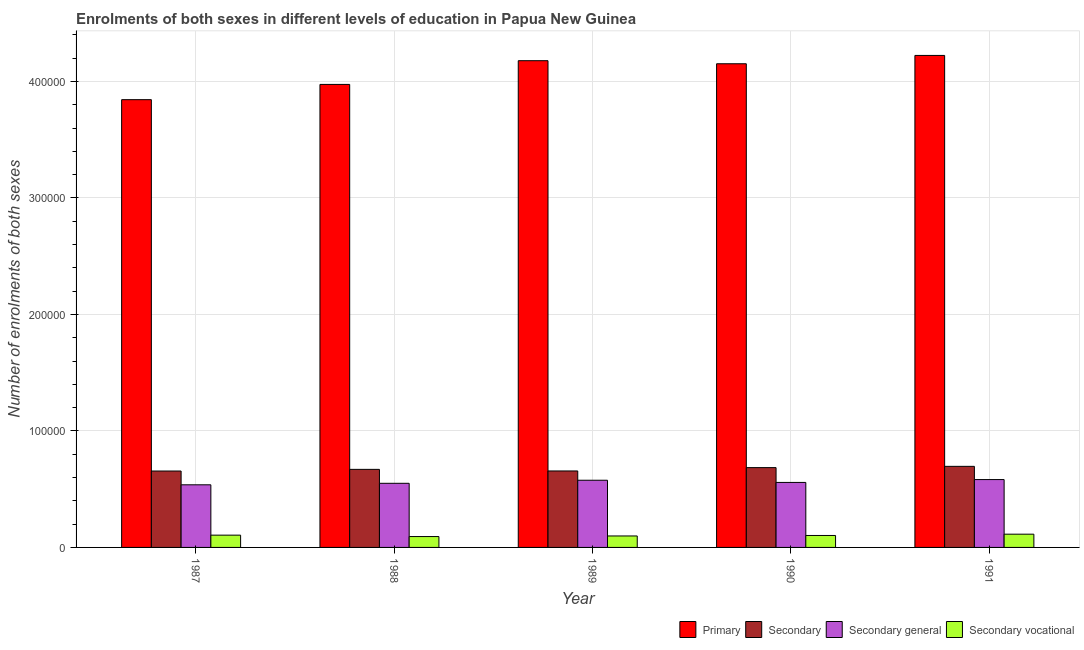Are the number of bars per tick equal to the number of legend labels?
Ensure brevity in your answer.  Yes. Are the number of bars on each tick of the X-axis equal?
Provide a succinct answer. Yes. How many bars are there on the 3rd tick from the left?
Provide a succinct answer. 4. What is the number of enrolments in secondary vocational education in 1990?
Your answer should be very brief. 1.03e+04. Across all years, what is the maximum number of enrolments in secondary vocational education?
Keep it short and to the point. 1.14e+04. Across all years, what is the minimum number of enrolments in secondary vocational education?
Your response must be concise. 9331. In which year was the number of enrolments in primary education maximum?
Your answer should be very brief. 1991. In which year was the number of enrolments in primary education minimum?
Your answer should be compact. 1987. What is the total number of enrolments in primary education in the graph?
Your response must be concise. 2.04e+06. What is the difference between the number of enrolments in primary education in 1987 and that in 1991?
Provide a succinct answer. -3.80e+04. What is the difference between the number of enrolments in secondary general education in 1988 and the number of enrolments in primary education in 1990?
Keep it short and to the point. -751. What is the average number of enrolments in secondary education per year?
Offer a terse response. 6.73e+04. In how many years, is the number of enrolments in primary education greater than 420000?
Make the answer very short. 1. What is the ratio of the number of enrolments in secondary education in 1988 to that in 1989?
Your answer should be very brief. 1.02. What is the difference between the highest and the second highest number of enrolments in secondary general education?
Give a very brief answer. 573. What is the difference between the highest and the lowest number of enrolments in secondary education?
Give a very brief answer. 4014. In how many years, is the number of enrolments in secondary vocational education greater than the average number of enrolments in secondary vocational education taken over all years?
Your answer should be very brief. 2. What does the 3rd bar from the left in 1989 represents?
Provide a short and direct response. Secondary general. What does the 3rd bar from the right in 1989 represents?
Offer a terse response. Secondary. Is it the case that in every year, the sum of the number of enrolments in primary education and number of enrolments in secondary education is greater than the number of enrolments in secondary general education?
Give a very brief answer. Yes. How many years are there in the graph?
Offer a very short reply. 5. What is the difference between two consecutive major ticks on the Y-axis?
Provide a succinct answer. 1.00e+05. Does the graph contain any zero values?
Ensure brevity in your answer.  No. How many legend labels are there?
Give a very brief answer. 4. What is the title of the graph?
Offer a terse response. Enrolments of both sexes in different levels of education in Papua New Guinea. What is the label or title of the X-axis?
Make the answer very short. Year. What is the label or title of the Y-axis?
Make the answer very short. Number of enrolments of both sexes. What is the Number of enrolments of both sexes of Primary in 1987?
Your answer should be compact. 3.84e+05. What is the Number of enrolments of both sexes of Secondary in 1987?
Your response must be concise. 6.56e+04. What is the Number of enrolments of both sexes of Secondary general in 1987?
Offer a terse response. 5.38e+04. What is the Number of enrolments of both sexes in Secondary vocational in 1987?
Provide a succinct answer. 1.05e+04. What is the Number of enrolments of both sexes in Primary in 1988?
Provide a short and direct response. 3.97e+05. What is the Number of enrolments of both sexes of Secondary in 1988?
Offer a terse response. 6.70e+04. What is the Number of enrolments of both sexes of Secondary general in 1988?
Give a very brief answer. 5.50e+04. What is the Number of enrolments of both sexes in Secondary vocational in 1988?
Offer a very short reply. 9331. What is the Number of enrolments of both sexes of Primary in 1989?
Provide a succinct answer. 4.18e+05. What is the Number of enrolments of both sexes in Secondary in 1989?
Your response must be concise. 6.56e+04. What is the Number of enrolments of both sexes of Secondary general in 1989?
Offer a very short reply. 5.77e+04. What is the Number of enrolments of both sexes of Secondary vocational in 1989?
Provide a succinct answer. 9846. What is the Number of enrolments of both sexes of Primary in 1990?
Keep it short and to the point. 4.15e+05. What is the Number of enrolments of both sexes in Secondary in 1990?
Give a very brief answer. 6.85e+04. What is the Number of enrolments of both sexes in Secondary general in 1990?
Your answer should be very brief. 5.58e+04. What is the Number of enrolments of both sexes in Secondary vocational in 1990?
Provide a succinct answer. 1.03e+04. What is the Number of enrolments of both sexes of Primary in 1991?
Provide a succinct answer. 4.22e+05. What is the Number of enrolments of both sexes of Secondary in 1991?
Provide a succinct answer. 6.96e+04. What is the Number of enrolments of both sexes in Secondary general in 1991?
Make the answer very short. 5.82e+04. What is the Number of enrolments of both sexes in Secondary vocational in 1991?
Your response must be concise. 1.14e+04. Across all years, what is the maximum Number of enrolments of both sexes of Primary?
Provide a short and direct response. 4.22e+05. Across all years, what is the maximum Number of enrolments of both sexes in Secondary?
Offer a terse response. 6.96e+04. Across all years, what is the maximum Number of enrolments of both sexes of Secondary general?
Ensure brevity in your answer.  5.82e+04. Across all years, what is the maximum Number of enrolments of both sexes of Secondary vocational?
Give a very brief answer. 1.14e+04. Across all years, what is the minimum Number of enrolments of both sexes of Primary?
Keep it short and to the point. 3.84e+05. Across all years, what is the minimum Number of enrolments of both sexes in Secondary?
Ensure brevity in your answer.  6.56e+04. Across all years, what is the minimum Number of enrolments of both sexes of Secondary general?
Keep it short and to the point. 5.38e+04. Across all years, what is the minimum Number of enrolments of both sexes of Secondary vocational?
Offer a terse response. 9331. What is the total Number of enrolments of both sexes in Primary in the graph?
Your answer should be very brief. 2.04e+06. What is the total Number of enrolments of both sexes of Secondary in the graph?
Keep it short and to the point. 3.36e+05. What is the total Number of enrolments of both sexes of Secondary general in the graph?
Your answer should be compact. 2.81e+05. What is the total Number of enrolments of both sexes of Secondary vocational in the graph?
Offer a terse response. 5.13e+04. What is the difference between the Number of enrolments of both sexes in Primary in 1987 and that in 1988?
Give a very brief answer. -1.31e+04. What is the difference between the Number of enrolments of both sexes of Secondary in 1987 and that in 1988?
Give a very brief answer. -1425. What is the difference between the Number of enrolments of both sexes of Secondary general in 1987 and that in 1988?
Ensure brevity in your answer.  -1294. What is the difference between the Number of enrolments of both sexes in Secondary vocational in 1987 and that in 1988?
Your response must be concise. 1205. What is the difference between the Number of enrolments of both sexes of Primary in 1987 and that in 1989?
Make the answer very short. -3.35e+04. What is the difference between the Number of enrolments of both sexes in Secondary in 1987 and that in 1989?
Your response must be concise. -61. What is the difference between the Number of enrolments of both sexes in Secondary general in 1987 and that in 1989?
Keep it short and to the point. -3924. What is the difference between the Number of enrolments of both sexes of Secondary vocational in 1987 and that in 1989?
Your answer should be compact. 690. What is the difference between the Number of enrolments of both sexes of Primary in 1987 and that in 1990?
Your answer should be compact. -3.08e+04. What is the difference between the Number of enrolments of both sexes in Secondary in 1987 and that in 1990?
Give a very brief answer. -2924. What is the difference between the Number of enrolments of both sexes in Secondary general in 1987 and that in 1990?
Your answer should be compact. -2045. What is the difference between the Number of enrolments of both sexes of Secondary vocational in 1987 and that in 1990?
Your answer should be very brief. 279. What is the difference between the Number of enrolments of both sexes in Primary in 1987 and that in 1991?
Your answer should be very brief. -3.80e+04. What is the difference between the Number of enrolments of both sexes of Secondary in 1987 and that in 1991?
Offer a terse response. -4014. What is the difference between the Number of enrolments of both sexes of Secondary general in 1987 and that in 1991?
Your answer should be compact. -4497. What is the difference between the Number of enrolments of both sexes in Secondary vocational in 1987 and that in 1991?
Provide a short and direct response. -834. What is the difference between the Number of enrolments of both sexes of Primary in 1988 and that in 1989?
Make the answer very short. -2.04e+04. What is the difference between the Number of enrolments of both sexes in Secondary in 1988 and that in 1989?
Ensure brevity in your answer.  1364. What is the difference between the Number of enrolments of both sexes of Secondary general in 1988 and that in 1989?
Your answer should be very brief. -2630. What is the difference between the Number of enrolments of both sexes in Secondary vocational in 1988 and that in 1989?
Your response must be concise. -515. What is the difference between the Number of enrolments of both sexes of Primary in 1988 and that in 1990?
Offer a terse response. -1.77e+04. What is the difference between the Number of enrolments of both sexes in Secondary in 1988 and that in 1990?
Provide a succinct answer. -1499. What is the difference between the Number of enrolments of both sexes of Secondary general in 1988 and that in 1990?
Provide a short and direct response. -751. What is the difference between the Number of enrolments of both sexes of Secondary vocational in 1988 and that in 1990?
Give a very brief answer. -926. What is the difference between the Number of enrolments of both sexes in Primary in 1988 and that in 1991?
Give a very brief answer. -2.49e+04. What is the difference between the Number of enrolments of both sexes in Secondary in 1988 and that in 1991?
Ensure brevity in your answer.  -2589. What is the difference between the Number of enrolments of both sexes in Secondary general in 1988 and that in 1991?
Your response must be concise. -3203. What is the difference between the Number of enrolments of both sexes in Secondary vocational in 1988 and that in 1991?
Your answer should be compact. -2039. What is the difference between the Number of enrolments of both sexes of Primary in 1989 and that in 1990?
Make the answer very short. 2623. What is the difference between the Number of enrolments of both sexes in Secondary in 1989 and that in 1990?
Provide a short and direct response. -2863. What is the difference between the Number of enrolments of both sexes of Secondary general in 1989 and that in 1990?
Make the answer very short. 1879. What is the difference between the Number of enrolments of both sexes in Secondary vocational in 1989 and that in 1990?
Give a very brief answer. -411. What is the difference between the Number of enrolments of both sexes of Primary in 1989 and that in 1991?
Give a very brief answer. -4530. What is the difference between the Number of enrolments of both sexes in Secondary in 1989 and that in 1991?
Ensure brevity in your answer.  -3953. What is the difference between the Number of enrolments of both sexes in Secondary general in 1989 and that in 1991?
Provide a succinct answer. -573. What is the difference between the Number of enrolments of both sexes in Secondary vocational in 1989 and that in 1991?
Offer a terse response. -1524. What is the difference between the Number of enrolments of both sexes in Primary in 1990 and that in 1991?
Your answer should be compact. -7153. What is the difference between the Number of enrolments of both sexes in Secondary in 1990 and that in 1991?
Offer a very short reply. -1090. What is the difference between the Number of enrolments of both sexes of Secondary general in 1990 and that in 1991?
Give a very brief answer. -2452. What is the difference between the Number of enrolments of both sexes in Secondary vocational in 1990 and that in 1991?
Your answer should be very brief. -1113. What is the difference between the Number of enrolments of both sexes in Primary in 1987 and the Number of enrolments of both sexes in Secondary in 1988?
Offer a very short reply. 3.17e+05. What is the difference between the Number of enrolments of both sexes of Primary in 1987 and the Number of enrolments of both sexes of Secondary general in 1988?
Provide a short and direct response. 3.29e+05. What is the difference between the Number of enrolments of both sexes of Primary in 1987 and the Number of enrolments of both sexes of Secondary vocational in 1988?
Offer a very short reply. 3.75e+05. What is the difference between the Number of enrolments of both sexes of Secondary in 1987 and the Number of enrolments of both sexes of Secondary general in 1988?
Offer a terse response. 1.05e+04. What is the difference between the Number of enrolments of both sexes in Secondary in 1987 and the Number of enrolments of both sexes in Secondary vocational in 1988?
Offer a terse response. 5.63e+04. What is the difference between the Number of enrolments of both sexes of Secondary general in 1987 and the Number of enrolments of both sexes of Secondary vocational in 1988?
Make the answer very short. 4.44e+04. What is the difference between the Number of enrolments of both sexes of Primary in 1987 and the Number of enrolments of both sexes of Secondary in 1989?
Provide a succinct answer. 3.19e+05. What is the difference between the Number of enrolments of both sexes in Primary in 1987 and the Number of enrolments of both sexes in Secondary general in 1989?
Your answer should be compact. 3.27e+05. What is the difference between the Number of enrolments of both sexes of Primary in 1987 and the Number of enrolments of both sexes of Secondary vocational in 1989?
Offer a terse response. 3.75e+05. What is the difference between the Number of enrolments of both sexes in Secondary in 1987 and the Number of enrolments of both sexes in Secondary general in 1989?
Ensure brevity in your answer.  7906. What is the difference between the Number of enrolments of both sexes in Secondary in 1987 and the Number of enrolments of both sexes in Secondary vocational in 1989?
Offer a terse response. 5.57e+04. What is the difference between the Number of enrolments of both sexes in Secondary general in 1987 and the Number of enrolments of both sexes in Secondary vocational in 1989?
Give a very brief answer. 4.39e+04. What is the difference between the Number of enrolments of both sexes of Primary in 1987 and the Number of enrolments of both sexes of Secondary in 1990?
Your answer should be very brief. 3.16e+05. What is the difference between the Number of enrolments of both sexes of Primary in 1987 and the Number of enrolments of both sexes of Secondary general in 1990?
Make the answer very short. 3.29e+05. What is the difference between the Number of enrolments of both sexes of Primary in 1987 and the Number of enrolments of both sexes of Secondary vocational in 1990?
Ensure brevity in your answer.  3.74e+05. What is the difference between the Number of enrolments of both sexes in Secondary in 1987 and the Number of enrolments of both sexes in Secondary general in 1990?
Offer a very short reply. 9785. What is the difference between the Number of enrolments of both sexes in Secondary in 1987 and the Number of enrolments of both sexes in Secondary vocational in 1990?
Offer a terse response. 5.53e+04. What is the difference between the Number of enrolments of both sexes of Secondary general in 1987 and the Number of enrolments of both sexes of Secondary vocational in 1990?
Your response must be concise. 4.35e+04. What is the difference between the Number of enrolments of both sexes of Primary in 1987 and the Number of enrolments of both sexes of Secondary in 1991?
Provide a succinct answer. 3.15e+05. What is the difference between the Number of enrolments of both sexes of Primary in 1987 and the Number of enrolments of both sexes of Secondary general in 1991?
Make the answer very short. 3.26e+05. What is the difference between the Number of enrolments of both sexes in Primary in 1987 and the Number of enrolments of both sexes in Secondary vocational in 1991?
Ensure brevity in your answer.  3.73e+05. What is the difference between the Number of enrolments of both sexes of Secondary in 1987 and the Number of enrolments of both sexes of Secondary general in 1991?
Make the answer very short. 7333. What is the difference between the Number of enrolments of both sexes in Secondary in 1987 and the Number of enrolments of both sexes in Secondary vocational in 1991?
Give a very brief answer. 5.42e+04. What is the difference between the Number of enrolments of both sexes of Secondary general in 1987 and the Number of enrolments of both sexes of Secondary vocational in 1991?
Ensure brevity in your answer.  4.24e+04. What is the difference between the Number of enrolments of both sexes in Primary in 1988 and the Number of enrolments of both sexes in Secondary in 1989?
Give a very brief answer. 3.32e+05. What is the difference between the Number of enrolments of both sexes in Primary in 1988 and the Number of enrolments of both sexes in Secondary general in 1989?
Give a very brief answer. 3.40e+05. What is the difference between the Number of enrolments of both sexes in Primary in 1988 and the Number of enrolments of both sexes in Secondary vocational in 1989?
Provide a succinct answer. 3.88e+05. What is the difference between the Number of enrolments of both sexes of Secondary in 1988 and the Number of enrolments of both sexes of Secondary general in 1989?
Provide a succinct answer. 9331. What is the difference between the Number of enrolments of both sexes of Secondary in 1988 and the Number of enrolments of both sexes of Secondary vocational in 1989?
Keep it short and to the point. 5.72e+04. What is the difference between the Number of enrolments of both sexes in Secondary general in 1988 and the Number of enrolments of both sexes in Secondary vocational in 1989?
Offer a terse response. 4.52e+04. What is the difference between the Number of enrolments of both sexes of Primary in 1988 and the Number of enrolments of both sexes of Secondary in 1990?
Keep it short and to the point. 3.29e+05. What is the difference between the Number of enrolments of both sexes in Primary in 1988 and the Number of enrolments of both sexes in Secondary general in 1990?
Offer a very short reply. 3.42e+05. What is the difference between the Number of enrolments of both sexes of Primary in 1988 and the Number of enrolments of both sexes of Secondary vocational in 1990?
Keep it short and to the point. 3.87e+05. What is the difference between the Number of enrolments of both sexes in Secondary in 1988 and the Number of enrolments of both sexes in Secondary general in 1990?
Your answer should be compact. 1.12e+04. What is the difference between the Number of enrolments of both sexes in Secondary in 1988 and the Number of enrolments of both sexes in Secondary vocational in 1990?
Offer a terse response. 5.68e+04. What is the difference between the Number of enrolments of both sexes in Secondary general in 1988 and the Number of enrolments of both sexes in Secondary vocational in 1990?
Ensure brevity in your answer.  4.48e+04. What is the difference between the Number of enrolments of both sexes of Primary in 1988 and the Number of enrolments of both sexes of Secondary in 1991?
Your answer should be very brief. 3.28e+05. What is the difference between the Number of enrolments of both sexes in Primary in 1988 and the Number of enrolments of both sexes in Secondary general in 1991?
Make the answer very short. 3.39e+05. What is the difference between the Number of enrolments of both sexes of Primary in 1988 and the Number of enrolments of both sexes of Secondary vocational in 1991?
Your answer should be compact. 3.86e+05. What is the difference between the Number of enrolments of both sexes of Secondary in 1988 and the Number of enrolments of both sexes of Secondary general in 1991?
Keep it short and to the point. 8758. What is the difference between the Number of enrolments of both sexes of Secondary in 1988 and the Number of enrolments of both sexes of Secondary vocational in 1991?
Give a very brief answer. 5.56e+04. What is the difference between the Number of enrolments of both sexes of Secondary general in 1988 and the Number of enrolments of both sexes of Secondary vocational in 1991?
Your answer should be very brief. 4.37e+04. What is the difference between the Number of enrolments of both sexes of Primary in 1989 and the Number of enrolments of both sexes of Secondary in 1990?
Your answer should be compact. 3.49e+05. What is the difference between the Number of enrolments of both sexes of Primary in 1989 and the Number of enrolments of both sexes of Secondary general in 1990?
Keep it short and to the point. 3.62e+05. What is the difference between the Number of enrolments of both sexes in Primary in 1989 and the Number of enrolments of both sexes in Secondary vocational in 1990?
Offer a very short reply. 4.08e+05. What is the difference between the Number of enrolments of both sexes in Secondary in 1989 and the Number of enrolments of both sexes in Secondary general in 1990?
Your response must be concise. 9846. What is the difference between the Number of enrolments of both sexes of Secondary in 1989 and the Number of enrolments of both sexes of Secondary vocational in 1990?
Keep it short and to the point. 5.54e+04. What is the difference between the Number of enrolments of both sexes in Secondary general in 1989 and the Number of enrolments of both sexes in Secondary vocational in 1990?
Give a very brief answer. 4.74e+04. What is the difference between the Number of enrolments of both sexes in Primary in 1989 and the Number of enrolments of both sexes in Secondary in 1991?
Give a very brief answer. 3.48e+05. What is the difference between the Number of enrolments of both sexes in Primary in 1989 and the Number of enrolments of both sexes in Secondary general in 1991?
Make the answer very short. 3.60e+05. What is the difference between the Number of enrolments of both sexes of Primary in 1989 and the Number of enrolments of both sexes of Secondary vocational in 1991?
Offer a terse response. 4.06e+05. What is the difference between the Number of enrolments of both sexes of Secondary in 1989 and the Number of enrolments of both sexes of Secondary general in 1991?
Your response must be concise. 7394. What is the difference between the Number of enrolments of both sexes in Secondary in 1989 and the Number of enrolments of both sexes in Secondary vocational in 1991?
Provide a short and direct response. 5.43e+04. What is the difference between the Number of enrolments of both sexes in Secondary general in 1989 and the Number of enrolments of both sexes in Secondary vocational in 1991?
Your response must be concise. 4.63e+04. What is the difference between the Number of enrolments of both sexes in Primary in 1990 and the Number of enrolments of both sexes in Secondary in 1991?
Your answer should be very brief. 3.46e+05. What is the difference between the Number of enrolments of both sexes of Primary in 1990 and the Number of enrolments of both sexes of Secondary general in 1991?
Your response must be concise. 3.57e+05. What is the difference between the Number of enrolments of both sexes in Primary in 1990 and the Number of enrolments of both sexes in Secondary vocational in 1991?
Offer a terse response. 4.04e+05. What is the difference between the Number of enrolments of both sexes of Secondary in 1990 and the Number of enrolments of both sexes of Secondary general in 1991?
Keep it short and to the point. 1.03e+04. What is the difference between the Number of enrolments of both sexes in Secondary in 1990 and the Number of enrolments of both sexes in Secondary vocational in 1991?
Give a very brief answer. 5.71e+04. What is the difference between the Number of enrolments of both sexes of Secondary general in 1990 and the Number of enrolments of both sexes of Secondary vocational in 1991?
Give a very brief answer. 4.44e+04. What is the average Number of enrolments of both sexes in Primary per year?
Offer a terse response. 4.07e+05. What is the average Number of enrolments of both sexes of Secondary per year?
Ensure brevity in your answer.  6.73e+04. What is the average Number of enrolments of both sexes of Secondary general per year?
Give a very brief answer. 5.61e+04. What is the average Number of enrolments of both sexes in Secondary vocational per year?
Your answer should be compact. 1.03e+04. In the year 1987, what is the difference between the Number of enrolments of both sexes of Primary and Number of enrolments of both sexes of Secondary?
Your answer should be compact. 3.19e+05. In the year 1987, what is the difference between the Number of enrolments of both sexes of Primary and Number of enrolments of both sexes of Secondary general?
Give a very brief answer. 3.31e+05. In the year 1987, what is the difference between the Number of enrolments of both sexes of Primary and Number of enrolments of both sexes of Secondary vocational?
Provide a succinct answer. 3.74e+05. In the year 1987, what is the difference between the Number of enrolments of both sexes in Secondary and Number of enrolments of both sexes in Secondary general?
Make the answer very short. 1.18e+04. In the year 1987, what is the difference between the Number of enrolments of both sexes of Secondary and Number of enrolments of both sexes of Secondary vocational?
Provide a short and direct response. 5.50e+04. In the year 1987, what is the difference between the Number of enrolments of both sexes in Secondary general and Number of enrolments of both sexes in Secondary vocational?
Make the answer very short. 4.32e+04. In the year 1988, what is the difference between the Number of enrolments of both sexes of Primary and Number of enrolments of both sexes of Secondary?
Provide a short and direct response. 3.30e+05. In the year 1988, what is the difference between the Number of enrolments of both sexes in Primary and Number of enrolments of both sexes in Secondary general?
Your answer should be very brief. 3.42e+05. In the year 1988, what is the difference between the Number of enrolments of both sexes of Primary and Number of enrolments of both sexes of Secondary vocational?
Provide a succinct answer. 3.88e+05. In the year 1988, what is the difference between the Number of enrolments of both sexes of Secondary and Number of enrolments of both sexes of Secondary general?
Offer a very short reply. 1.20e+04. In the year 1988, what is the difference between the Number of enrolments of both sexes in Secondary and Number of enrolments of both sexes in Secondary vocational?
Keep it short and to the point. 5.77e+04. In the year 1988, what is the difference between the Number of enrolments of both sexes of Secondary general and Number of enrolments of both sexes of Secondary vocational?
Make the answer very short. 4.57e+04. In the year 1989, what is the difference between the Number of enrolments of both sexes in Primary and Number of enrolments of both sexes in Secondary?
Provide a succinct answer. 3.52e+05. In the year 1989, what is the difference between the Number of enrolments of both sexes in Primary and Number of enrolments of both sexes in Secondary general?
Provide a short and direct response. 3.60e+05. In the year 1989, what is the difference between the Number of enrolments of both sexes of Primary and Number of enrolments of both sexes of Secondary vocational?
Your answer should be very brief. 4.08e+05. In the year 1989, what is the difference between the Number of enrolments of both sexes in Secondary and Number of enrolments of both sexes in Secondary general?
Offer a very short reply. 7967. In the year 1989, what is the difference between the Number of enrolments of both sexes in Secondary and Number of enrolments of both sexes in Secondary vocational?
Offer a very short reply. 5.58e+04. In the year 1989, what is the difference between the Number of enrolments of both sexes of Secondary general and Number of enrolments of both sexes of Secondary vocational?
Offer a very short reply. 4.78e+04. In the year 1990, what is the difference between the Number of enrolments of both sexes of Primary and Number of enrolments of both sexes of Secondary?
Provide a short and direct response. 3.47e+05. In the year 1990, what is the difference between the Number of enrolments of both sexes of Primary and Number of enrolments of both sexes of Secondary general?
Keep it short and to the point. 3.59e+05. In the year 1990, what is the difference between the Number of enrolments of both sexes of Primary and Number of enrolments of both sexes of Secondary vocational?
Make the answer very short. 4.05e+05. In the year 1990, what is the difference between the Number of enrolments of both sexes of Secondary and Number of enrolments of both sexes of Secondary general?
Your response must be concise. 1.27e+04. In the year 1990, what is the difference between the Number of enrolments of both sexes of Secondary and Number of enrolments of both sexes of Secondary vocational?
Keep it short and to the point. 5.82e+04. In the year 1990, what is the difference between the Number of enrolments of both sexes in Secondary general and Number of enrolments of both sexes in Secondary vocational?
Your answer should be very brief. 4.55e+04. In the year 1991, what is the difference between the Number of enrolments of both sexes of Primary and Number of enrolments of both sexes of Secondary?
Ensure brevity in your answer.  3.53e+05. In the year 1991, what is the difference between the Number of enrolments of both sexes of Primary and Number of enrolments of both sexes of Secondary general?
Give a very brief answer. 3.64e+05. In the year 1991, what is the difference between the Number of enrolments of both sexes in Primary and Number of enrolments of both sexes in Secondary vocational?
Give a very brief answer. 4.11e+05. In the year 1991, what is the difference between the Number of enrolments of both sexes of Secondary and Number of enrolments of both sexes of Secondary general?
Your answer should be compact. 1.13e+04. In the year 1991, what is the difference between the Number of enrolments of both sexes of Secondary and Number of enrolments of both sexes of Secondary vocational?
Offer a very short reply. 5.82e+04. In the year 1991, what is the difference between the Number of enrolments of both sexes of Secondary general and Number of enrolments of both sexes of Secondary vocational?
Provide a succinct answer. 4.69e+04. What is the ratio of the Number of enrolments of both sexes in Primary in 1987 to that in 1988?
Your response must be concise. 0.97. What is the ratio of the Number of enrolments of both sexes in Secondary in 1987 to that in 1988?
Keep it short and to the point. 0.98. What is the ratio of the Number of enrolments of both sexes in Secondary general in 1987 to that in 1988?
Keep it short and to the point. 0.98. What is the ratio of the Number of enrolments of both sexes of Secondary vocational in 1987 to that in 1988?
Make the answer very short. 1.13. What is the ratio of the Number of enrolments of both sexes of Primary in 1987 to that in 1989?
Provide a short and direct response. 0.92. What is the ratio of the Number of enrolments of both sexes of Secondary in 1987 to that in 1989?
Your answer should be very brief. 1. What is the ratio of the Number of enrolments of both sexes of Secondary general in 1987 to that in 1989?
Your answer should be compact. 0.93. What is the ratio of the Number of enrolments of both sexes of Secondary vocational in 1987 to that in 1989?
Your response must be concise. 1.07. What is the ratio of the Number of enrolments of both sexes of Primary in 1987 to that in 1990?
Ensure brevity in your answer.  0.93. What is the ratio of the Number of enrolments of both sexes of Secondary in 1987 to that in 1990?
Keep it short and to the point. 0.96. What is the ratio of the Number of enrolments of both sexes in Secondary general in 1987 to that in 1990?
Offer a terse response. 0.96. What is the ratio of the Number of enrolments of both sexes in Secondary vocational in 1987 to that in 1990?
Ensure brevity in your answer.  1.03. What is the ratio of the Number of enrolments of both sexes of Primary in 1987 to that in 1991?
Provide a short and direct response. 0.91. What is the ratio of the Number of enrolments of both sexes in Secondary in 1987 to that in 1991?
Provide a short and direct response. 0.94. What is the ratio of the Number of enrolments of both sexes of Secondary general in 1987 to that in 1991?
Ensure brevity in your answer.  0.92. What is the ratio of the Number of enrolments of both sexes of Secondary vocational in 1987 to that in 1991?
Provide a short and direct response. 0.93. What is the ratio of the Number of enrolments of both sexes of Primary in 1988 to that in 1989?
Give a very brief answer. 0.95. What is the ratio of the Number of enrolments of both sexes in Secondary in 1988 to that in 1989?
Give a very brief answer. 1.02. What is the ratio of the Number of enrolments of both sexes of Secondary general in 1988 to that in 1989?
Offer a terse response. 0.95. What is the ratio of the Number of enrolments of both sexes in Secondary vocational in 1988 to that in 1989?
Make the answer very short. 0.95. What is the ratio of the Number of enrolments of both sexes of Primary in 1988 to that in 1990?
Provide a succinct answer. 0.96. What is the ratio of the Number of enrolments of both sexes in Secondary in 1988 to that in 1990?
Give a very brief answer. 0.98. What is the ratio of the Number of enrolments of both sexes of Secondary general in 1988 to that in 1990?
Provide a short and direct response. 0.99. What is the ratio of the Number of enrolments of both sexes of Secondary vocational in 1988 to that in 1990?
Make the answer very short. 0.91. What is the ratio of the Number of enrolments of both sexes in Primary in 1988 to that in 1991?
Provide a short and direct response. 0.94. What is the ratio of the Number of enrolments of both sexes of Secondary in 1988 to that in 1991?
Make the answer very short. 0.96. What is the ratio of the Number of enrolments of both sexes in Secondary general in 1988 to that in 1991?
Your answer should be very brief. 0.94. What is the ratio of the Number of enrolments of both sexes of Secondary vocational in 1988 to that in 1991?
Your response must be concise. 0.82. What is the ratio of the Number of enrolments of both sexes of Primary in 1989 to that in 1990?
Give a very brief answer. 1.01. What is the ratio of the Number of enrolments of both sexes in Secondary in 1989 to that in 1990?
Give a very brief answer. 0.96. What is the ratio of the Number of enrolments of both sexes in Secondary general in 1989 to that in 1990?
Your answer should be very brief. 1.03. What is the ratio of the Number of enrolments of both sexes in Secondary vocational in 1989 to that in 1990?
Provide a short and direct response. 0.96. What is the ratio of the Number of enrolments of both sexes in Primary in 1989 to that in 1991?
Give a very brief answer. 0.99. What is the ratio of the Number of enrolments of both sexes of Secondary in 1989 to that in 1991?
Ensure brevity in your answer.  0.94. What is the ratio of the Number of enrolments of both sexes in Secondary general in 1989 to that in 1991?
Offer a terse response. 0.99. What is the ratio of the Number of enrolments of both sexes of Secondary vocational in 1989 to that in 1991?
Keep it short and to the point. 0.87. What is the ratio of the Number of enrolments of both sexes in Primary in 1990 to that in 1991?
Offer a terse response. 0.98. What is the ratio of the Number of enrolments of both sexes in Secondary in 1990 to that in 1991?
Ensure brevity in your answer.  0.98. What is the ratio of the Number of enrolments of both sexes in Secondary general in 1990 to that in 1991?
Provide a succinct answer. 0.96. What is the ratio of the Number of enrolments of both sexes in Secondary vocational in 1990 to that in 1991?
Offer a very short reply. 0.9. What is the difference between the highest and the second highest Number of enrolments of both sexes of Primary?
Provide a succinct answer. 4530. What is the difference between the highest and the second highest Number of enrolments of both sexes of Secondary?
Make the answer very short. 1090. What is the difference between the highest and the second highest Number of enrolments of both sexes of Secondary general?
Offer a terse response. 573. What is the difference between the highest and the second highest Number of enrolments of both sexes of Secondary vocational?
Provide a short and direct response. 834. What is the difference between the highest and the lowest Number of enrolments of both sexes of Primary?
Your response must be concise. 3.80e+04. What is the difference between the highest and the lowest Number of enrolments of both sexes in Secondary?
Make the answer very short. 4014. What is the difference between the highest and the lowest Number of enrolments of both sexes in Secondary general?
Give a very brief answer. 4497. What is the difference between the highest and the lowest Number of enrolments of both sexes in Secondary vocational?
Ensure brevity in your answer.  2039. 